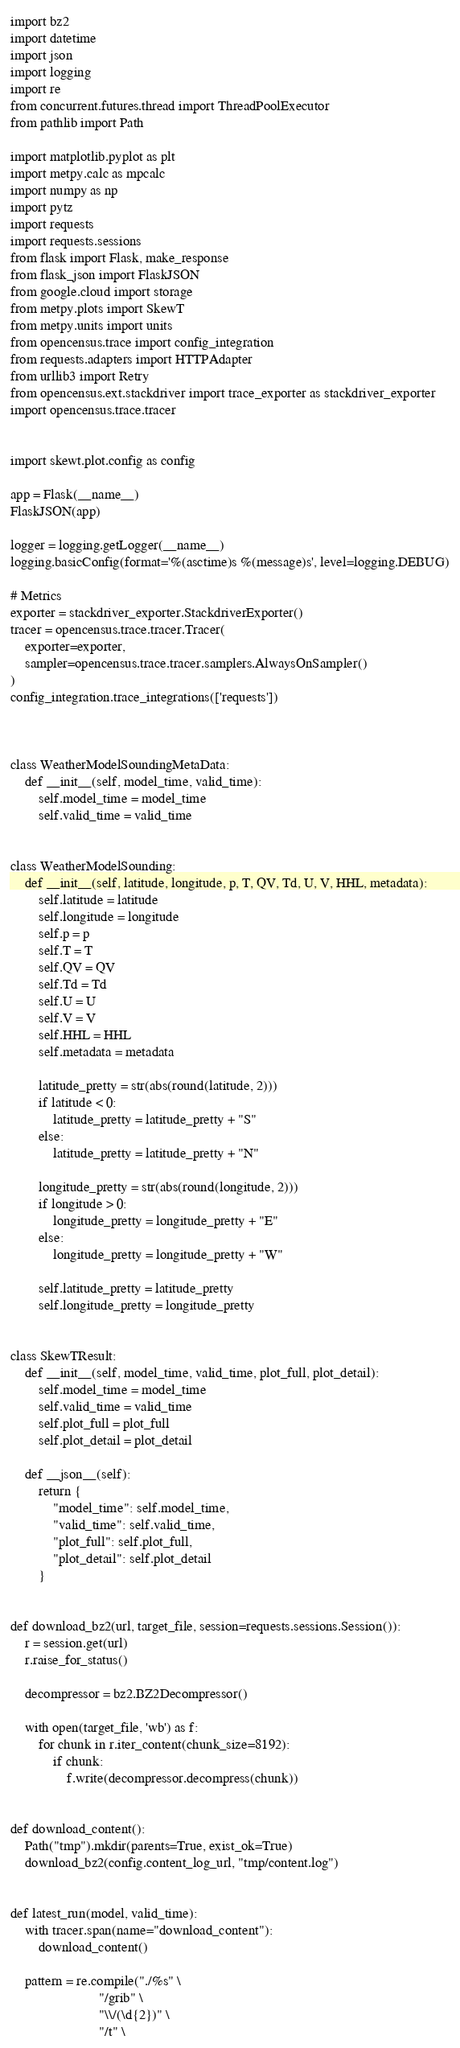Convert code to text. <code><loc_0><loc_0><loc_500><loc_500><_Python_>import bz2
import datetime
import json
import logging
import re
from concurrent.futures.thread import ThreadPoolExecutor
from pathlib import Path

import matplotlib.pyplot as plt
import metpy.calc as mpcalc
import numpy as np
import pytz
import requests
import requests.sessions
from flask import Flask, make_response
from flask_json import FlaskJSON
from google.cloud import storage
from metpy.plots import SkewT
from metpy.units import units
from opencensus.trace import config_integration
from requests.adapters import HTTPAdapter
from urllib3 import Retry
from opencensus.ext.stackdriver import trace_exporter as stackdriver_exporter
import opencensus.trace.tracer


import skewt.plot.config as config

app = Flask(__name__)
FlaskJSON(app)

logger = logging.getLogger(__name__)
logging.basicConfig(format='%(asctime)s %(message)s', level=logging.DEBUG)

# Metrics
exporter = stackdriver_exporter.StackdriverExporter()
tracer = opencensus.trace.tracer.Tracer(
    exporter=exporter,
    sampler=opencensus.trace.tracer.samplers.AlwaysOnSampler()
)
config_integration.trace_integrations(['requests'])



class WeatherModelSoundingMetaData:
    def __init__(self, model_time, valid_time):
        self.model_time = model_time
        self.valid_time = valid_time


class WeatherModelSounding:
    def __init__(self, latitude, longitude, p, T, QV, Td, U, V, HHL, metadata):
        self.latitude = latitude
        self.longitude = longitude
        self.p = p
        self.T = T
        self.QV = QV
        self.Td = Td
        self.U = U
        self.V = V
        self.HHL = HHL
        self.metadata = metadata

        latitude_pretty = str(abs(round(latitude, 2)))
        if latitude < 0:
            latitude_pretty = latitude_pretty + "S"
        else:
            latitude_pretty = latitude_pretty + "N"

        longitude_pretty = str(abs(round(longitude, 2)))
        if longitude > 0:
            longitude_pretty = longitude_pretty + "E"
        else:
            longitude_pretty = longitude_pretty + "W"

        self.latitude_pretty = latitude_pretty
        self.longitude_pretty = longitude_pretty


class SkewTResult:
    def __init__(self, model_time, valid_time, plot_full, plot_detail):
        self.model_time = model_time
        self.valid_time = valid_time
        self.plot_full = plot_full
        self.plot_detail = plot_detail

    def __json__(self):
        return {
            "model_time": self.model_time,
            "valid_time": self.valid_time,
            "plot_full": self.plot_full,
            "plot_detail": self.plot_detail
        }


def download_bz2(url, target_file, session=requests.sessions.Session()):
    r = session.get(url)
    r.raise_for_status()

    decompressor = bz2.BZ2Decompressor()

    with open(target_file, 'wb') as f:
        for chunk in r.iter_content(chunk_size=8192):
            if chunk:
                f.write(decompressor.decompress(chunk))


def download_content():
    Path("tmp").mkdir(parents=True, exist_ok=True)
    download_bz2(config.content_log_url, "tmp/content.log")


def latest_run(model, valid_time):
    with tracer.span(name="download_content"):
        download_content()

    pattern = re.compile("./%s" \
                         "/grib" \
                         "\\/(\d{2})" \
                         "/t" \</code> 